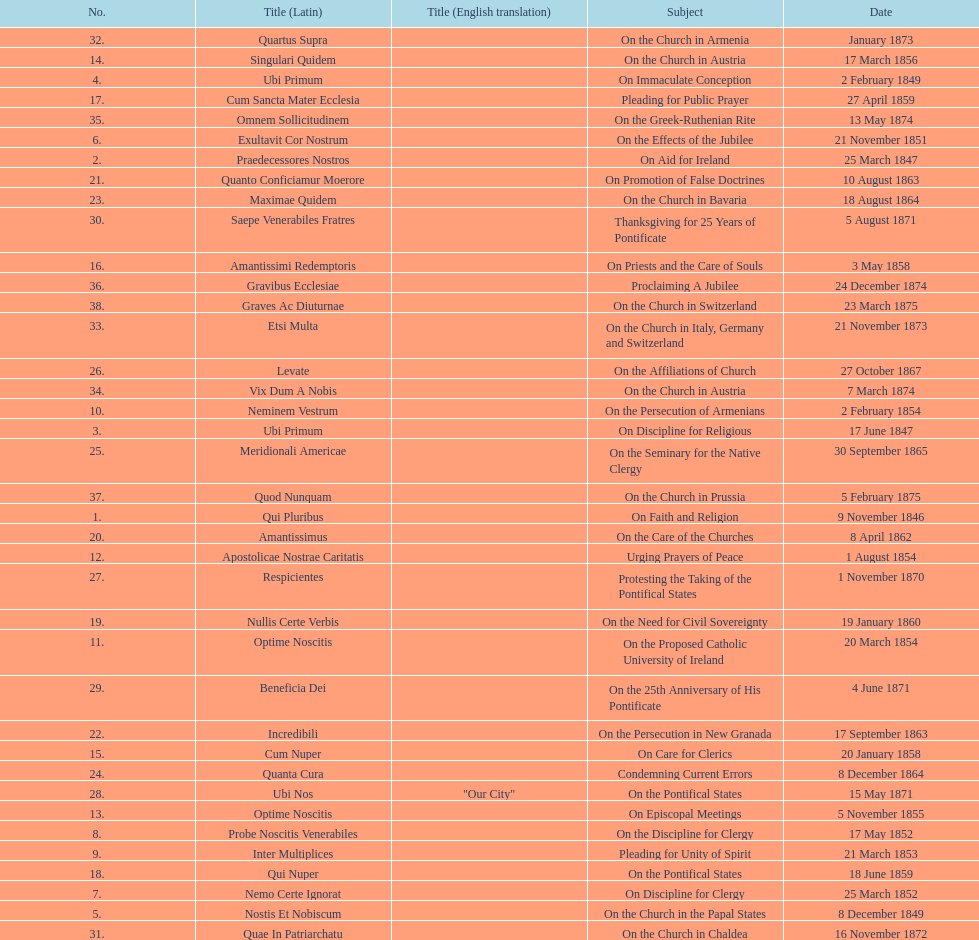Date of the last encyclical whose subject contained the word "pontificate" 5 August 1871. 